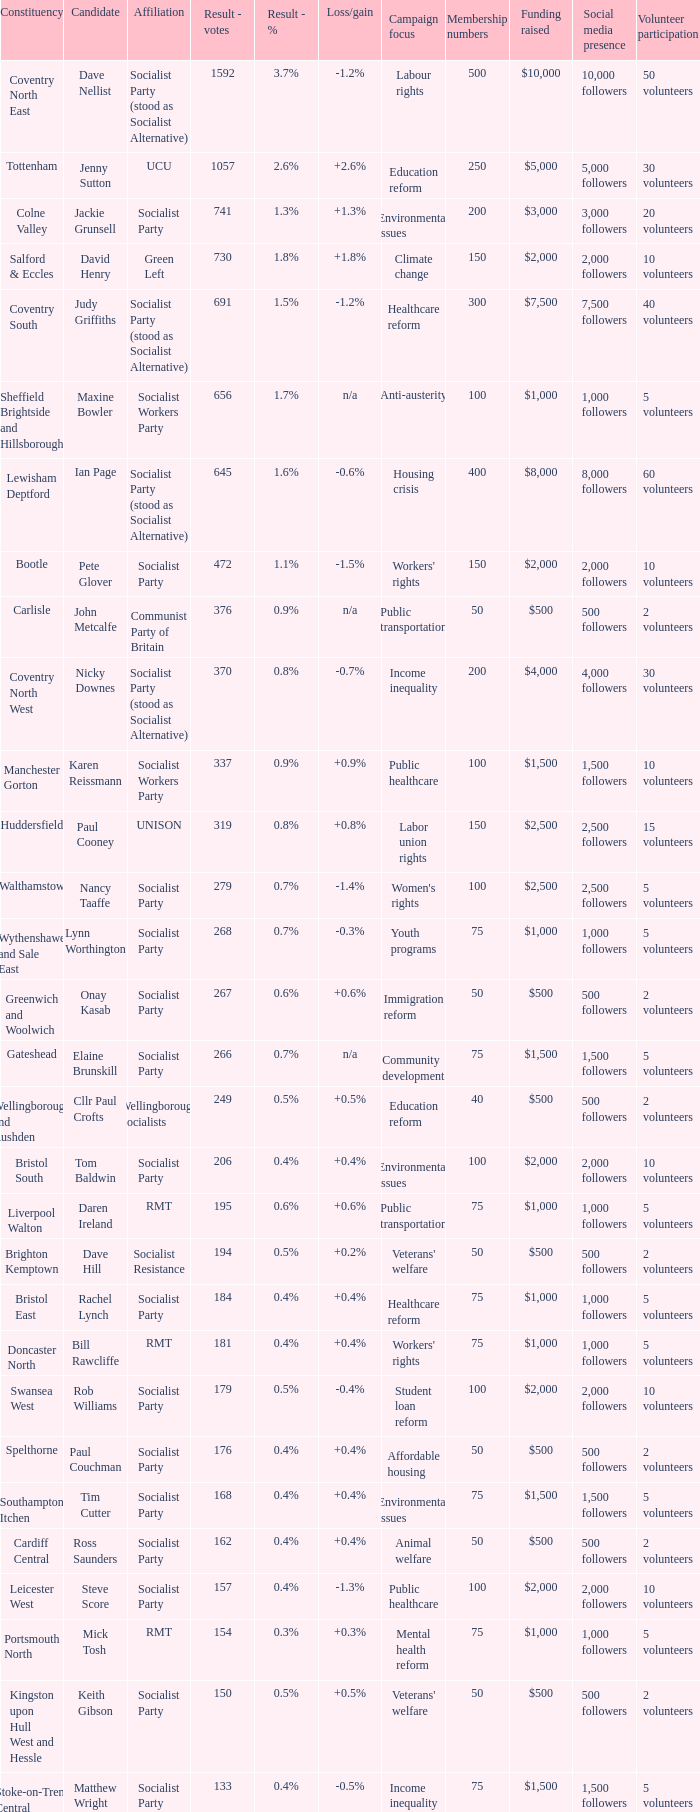What are all associations for candidate daren ireland? RMT. 